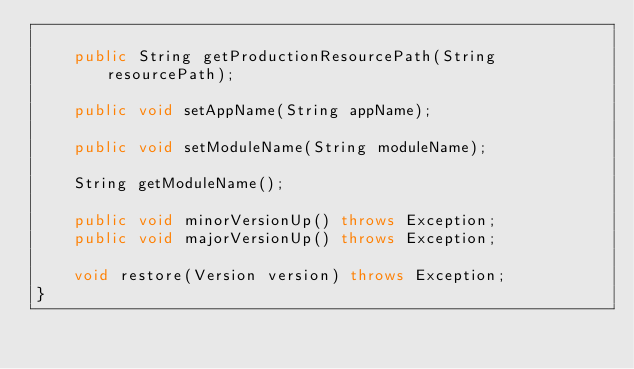Convert code to text. <code><loc_0><loc_0><loc_500><loc_500><_Java_>
    public String getProductionResourcePath(String resourcePath);

    public void setAppName(String appName);

    public void setModuleName(String moduleName);

    String getModuleName();

    public void minorVersionUp() throws Exception;
    public void majorVersionUp() throws Exception;

    void restore(Version version) throws Exception;
}
</code> 